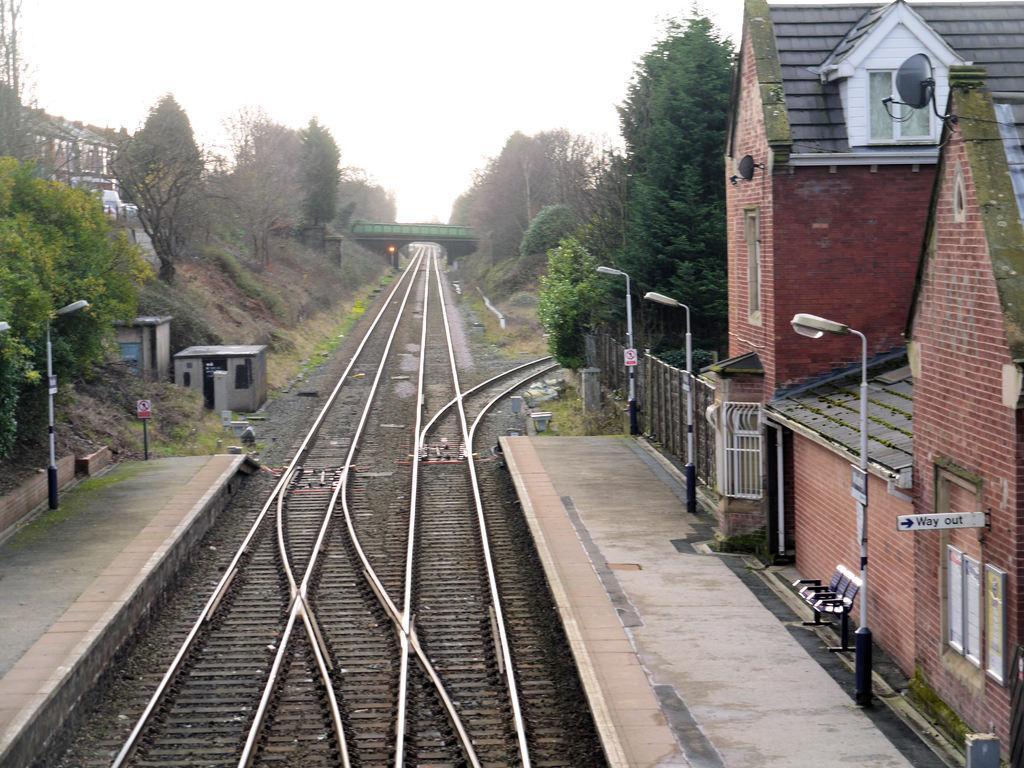Describe this image in one or two sentences. In the center of the image we can see railway tracks and there is a bridge. On the right there are sheds and poles. In the background there are trees and sky. We can see a bench. 